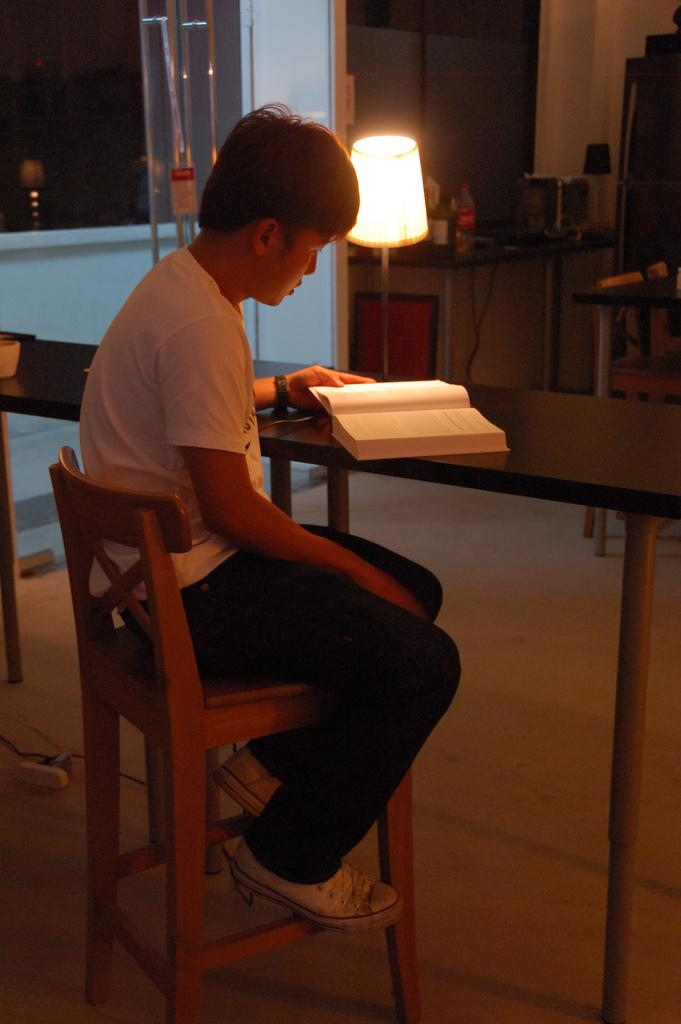What can be seen through the window in the image? The details about the view through the window are not provided in the facts. What type of lighting is present in the image? There is a lamp in the image, which provides lighting. What is on the table in the image? There is a book on the table in the image. What is the boy doing in the image? The boy is sitting on a chair in the image. What type of magic is the boy performing in the image? There is no mention of magic or any magical elements in the image. 